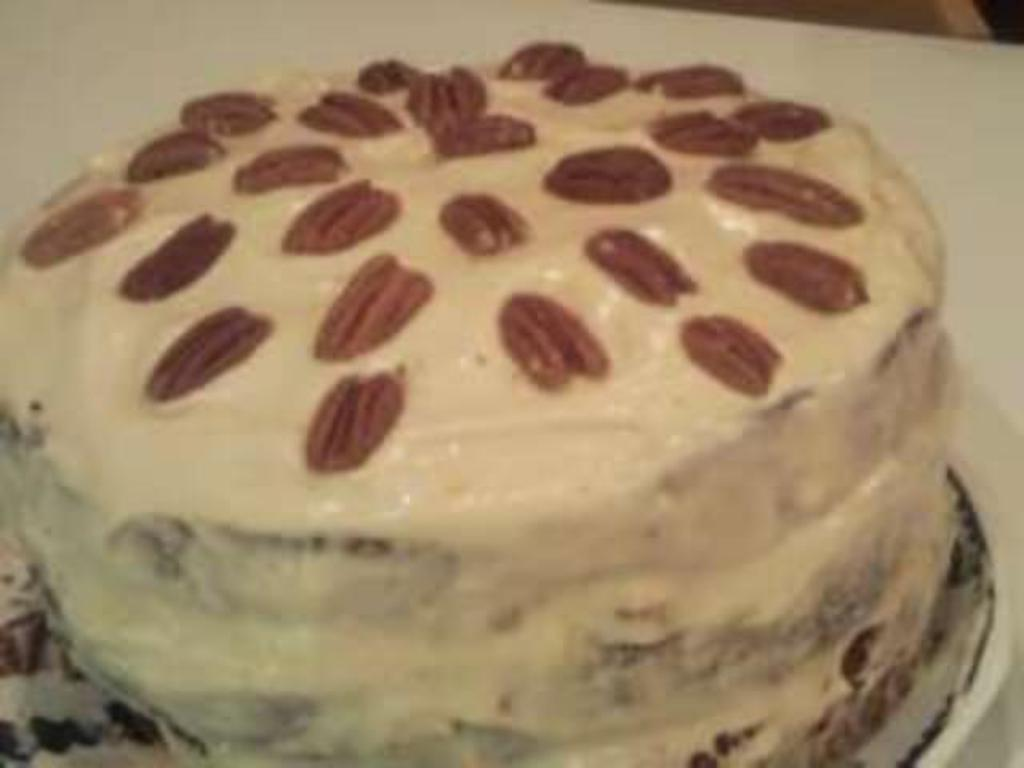What is the main subject of the image? There is a cake in the image. What decorations can be seen on the cake? There are sprinkles on the cake. On what surface is the cake placed? The cake is placed on a white surface. What type of protest is taking place in the image? There is no protest present in the image; it features a cake with sprinkles on a white surface. What color of gold can be seen on the cake? There is no gold present on the cake; it is decorated with sprinkles. 